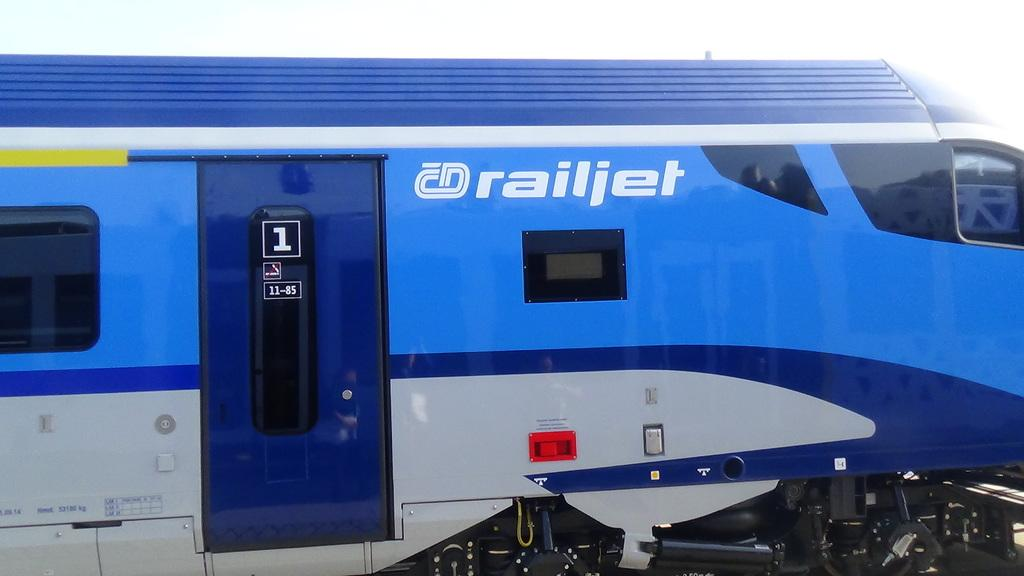What is the main subject of the picture? The main subject of the picture is a blue train. Can you describe any specific features of the train? Yes, there is writing on the train. Where is the worm located in the image? There is no worm present in the image. What type of desk can be seen in the image? There is no desk present in the image. 